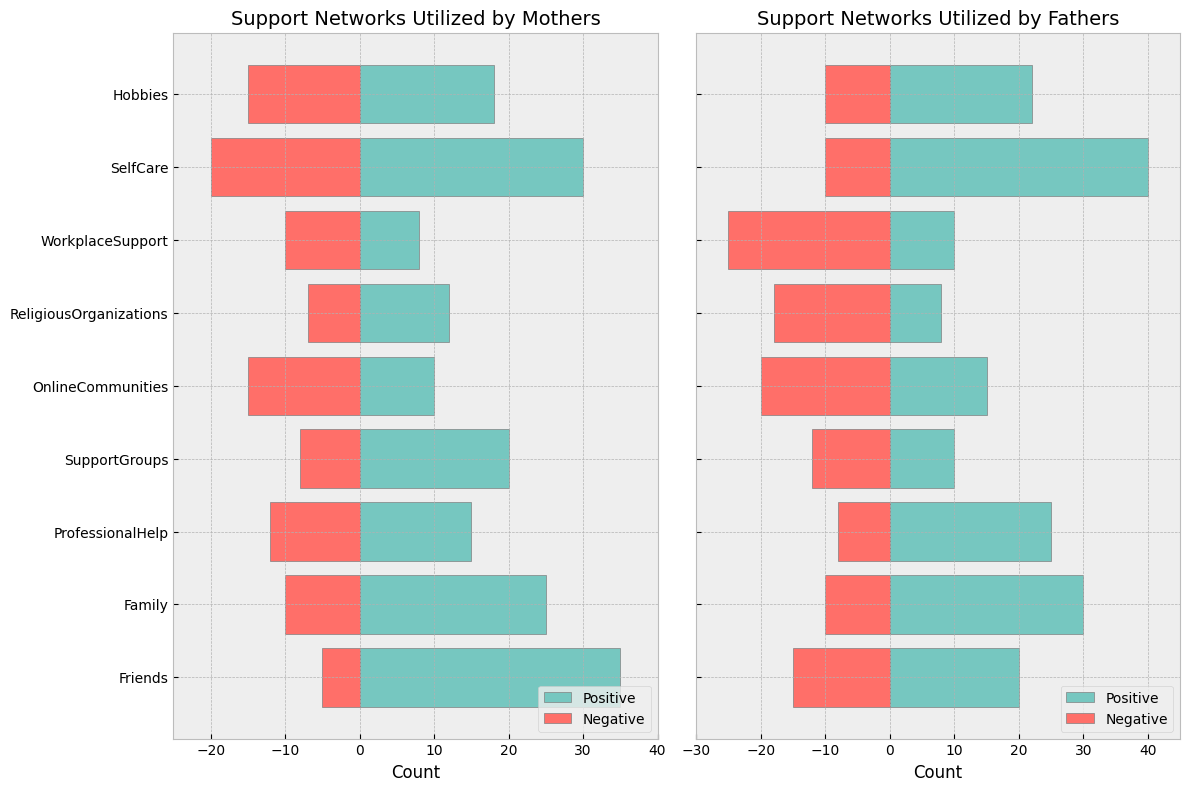Which support network has the highest positive response among fathers? From the bar chart for fathers, the highest positive bar corresponds to "SelfCare".
Answer: SelfCare What is the difference in the positive responses between mothers and fathers for "Friends"? The positive response for mothers for "Friends" is 35, and for fathers, it is 20. The difference is 35 - 20 = 15.
Answer: 15 Which support network has a greater negative response among fathers compared to mothers and by how much? Comparing the negative responses: Friends (M: 5, F: 15), Family (M: 10, F: 10), ProfessionalHelp (M: 12, F: 8), SupportGroups (M: 8, F: 12), OnlineCommunities (M: 15, F: 20), ReligiousOrganizations (M: 7, F: 18), WorkplaceSupport (M: 10, F: 25), SelfCare (M: 20, F: 10), Hobbies (M: 15, F: 10). WorkplaceSupport has a greater negative response in fathers (25) compared to mothers (10). The difference is 25 - 10 = 15.
Answer: WorkplaceSupport by 15 Are mothers more positive or negative about "OnlineCommunities"? For "OnlineCommunities", mothers have 10 positive responses and 15 negative responses. Since 10 < 15, mothers are more negative.
Answer: More negative Which support network has an equal positive response for both mothers and fathers? Evaluating the positive responses side-by-side: Friends (M: 35, F: 20), Family (M: 25, F: 30), ProfessionalHelp (M: 15, F: 25), SupportGroups (M: 20, F: 10), OnlineCommunities (M: 10, F: 15), ReligiousOrganizations (M: 12, F: 8), WorkplaceSupport (M: 8, F: 10), SelfCare (M: 30, F: 40), Hobbies (M: 18, F: 22). None of these responses are equal.
Answer: None How many support networks have fathers using them with negative feedback of 20 or more? By examining the visual heights of negative bars for fathers: OnlineCommunities (20), ReligiousOrganizations (18), WorkplaceSupport (25) show bars with 20 or more. Only OnlineCommunities and WorkplaceSupport meet the criteria.
Answer: 2 What is the cumulative positive response for fathers across all support networks? Summing the positive response values for fathers: 20 (Friends) + 30 (Family) + 25 (ProfessionalHelp) + 10 (SupportGroups) + 15 (OnlineCommunities) + 8 (ReligiousOrganizations) + 10 (WorkplaceSupport) + 40 (SelfCare) + 22 (Hobbies) = 180
Answer: 180 